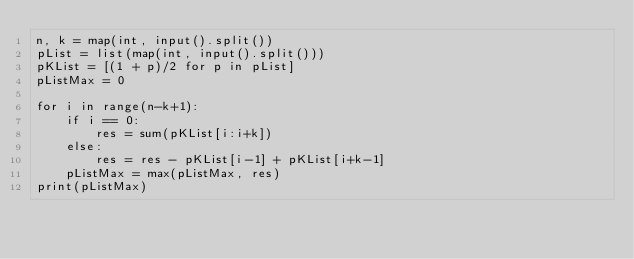Convert code to text. <code><loc_0><loc_0><loc_500><loc_500><_Python_>n, k = map(int, input().split())
pList = list(map(int, input().split()))
pKList = [(1 + p)/2 for p in pList]
pListMax = 0

for i in range(n-k+1):
    if i == 0:
        res = sum(pKList[i:i+k])
    else:
        res = res - pKList[i-1] + pKList[i+k-1]
    pListMax = max(pListMax, res)
print(pListMax)
</code> 